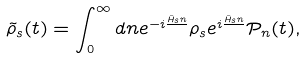<formula> <loc_0><loc_0><loc_500><loc_500>\tilde { \rho } _ { s } ( t ) = \int _ { 0 } ^ { \infty } d n e ^ { - i \frac { \hat { H } _ { s } n } { } } \rho _ { s } e ^ { i \frac { \hat { H } _ { s } n } { } } \mathcal { P } _ { n } ( t ) ,</formula> 